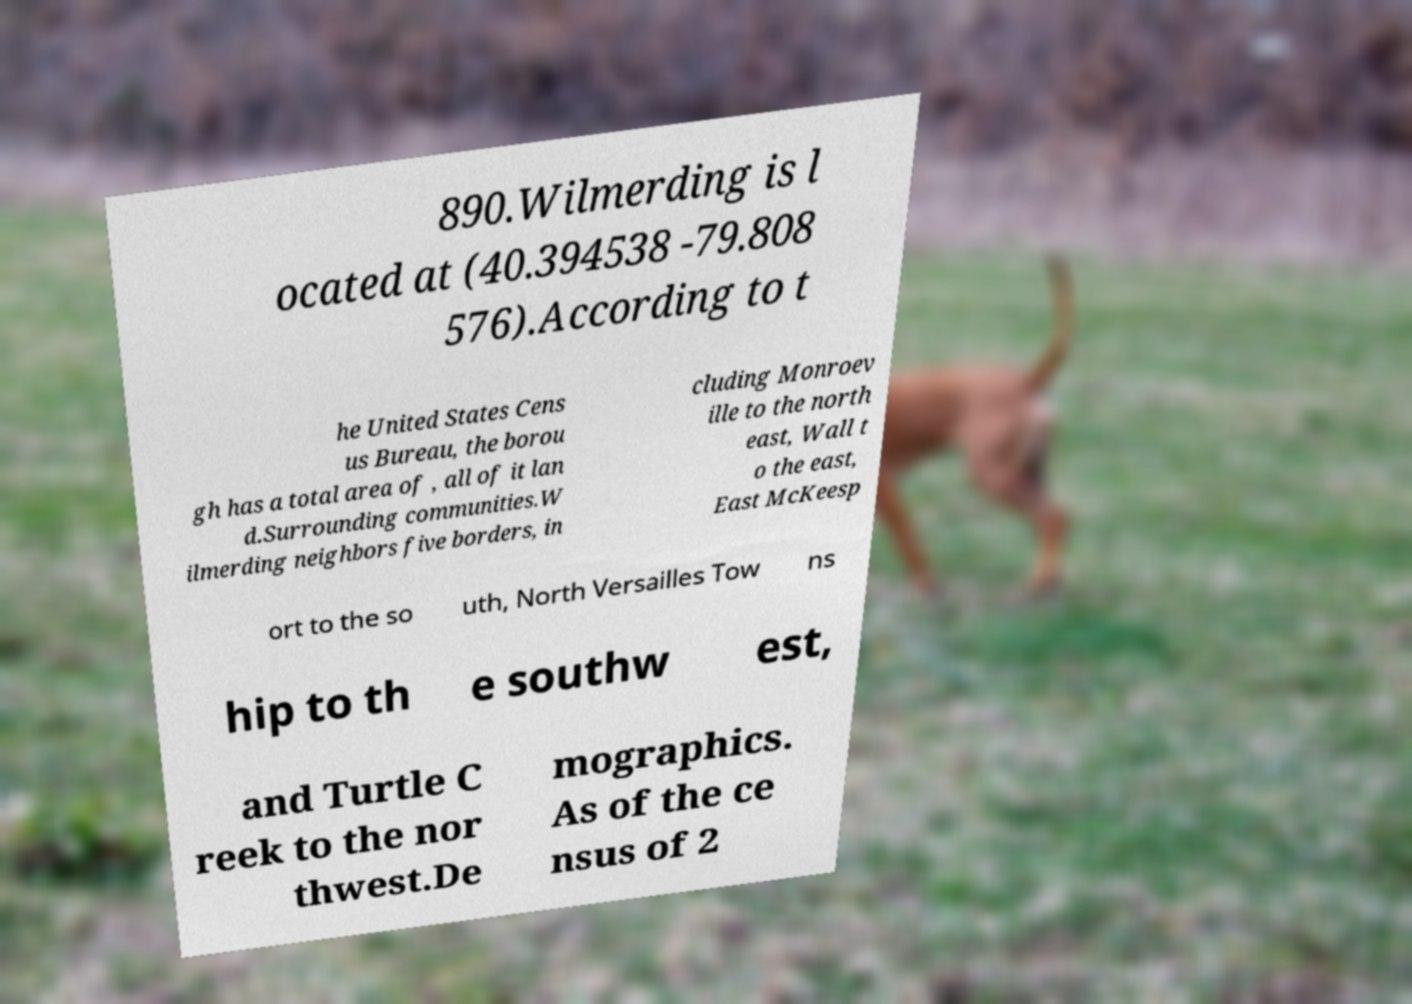There's text embedded in this image that I need extracted. Can you transcribe it verbatim? 890.Wilmerding is l ocated at (40.394538 -79.808 576).According to t he United States Cens us Bureau, the borou gh has a total area of , all of it lan d.Surrounding communities.W ilmerding neighbors five borders, in cluding Monroev ille to the north east, Wall t o the east, East McKeesp ort to the so uth, North Versailles Tow ns hip to th e southw est, and Turtle C reek to the nor thwest.De mographics. As of the ce nsus of 2 